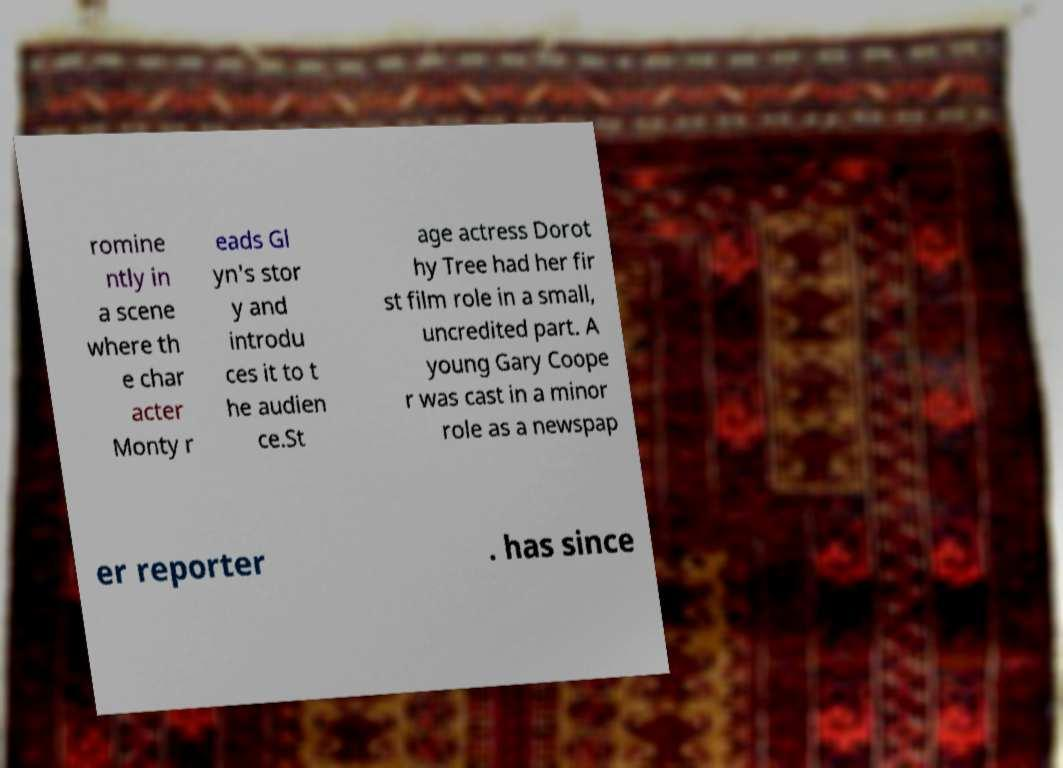There's text embedded in this image that I need extracted. Can you transcribe it verbatim? romine ntly in a scene where th e char acter Monty r eads Gl yn's stor y and introdu ces it to t he audien ce.St age actress Dorot hy Tree had her fir st film role in a small, uncredited part. A young Gary Coope r was cast in a minor role as a newspap er reporter . has since 